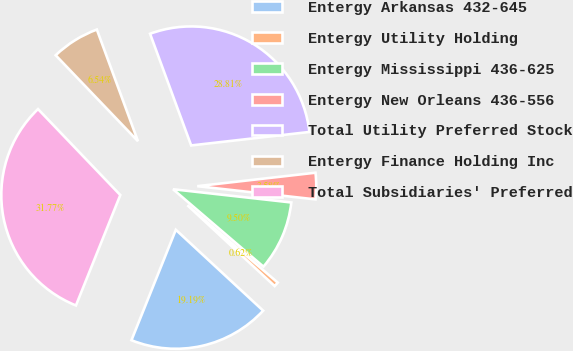<chart> <loc_0><loc_0><loc_500><loc_500><pie_chart><fcel>Entergy Arkansas 432-645<fcel>Entergy Utility Holding<fcel>Entergy Mississippi 436-625<fcel>Entergy New Orleans 436-556<fcel>Total Utility Preferred Stock<fcel>Entergy Finance Holding Inc<fcel>Total Subsidiaries' Preferred<nl><fcel>19.19%<fcel>0.62%<fcel>9.5%<fcel>3.58%<fcel>28.81%<fcel>6.54%<fcel>31.77%<nl></chart> 